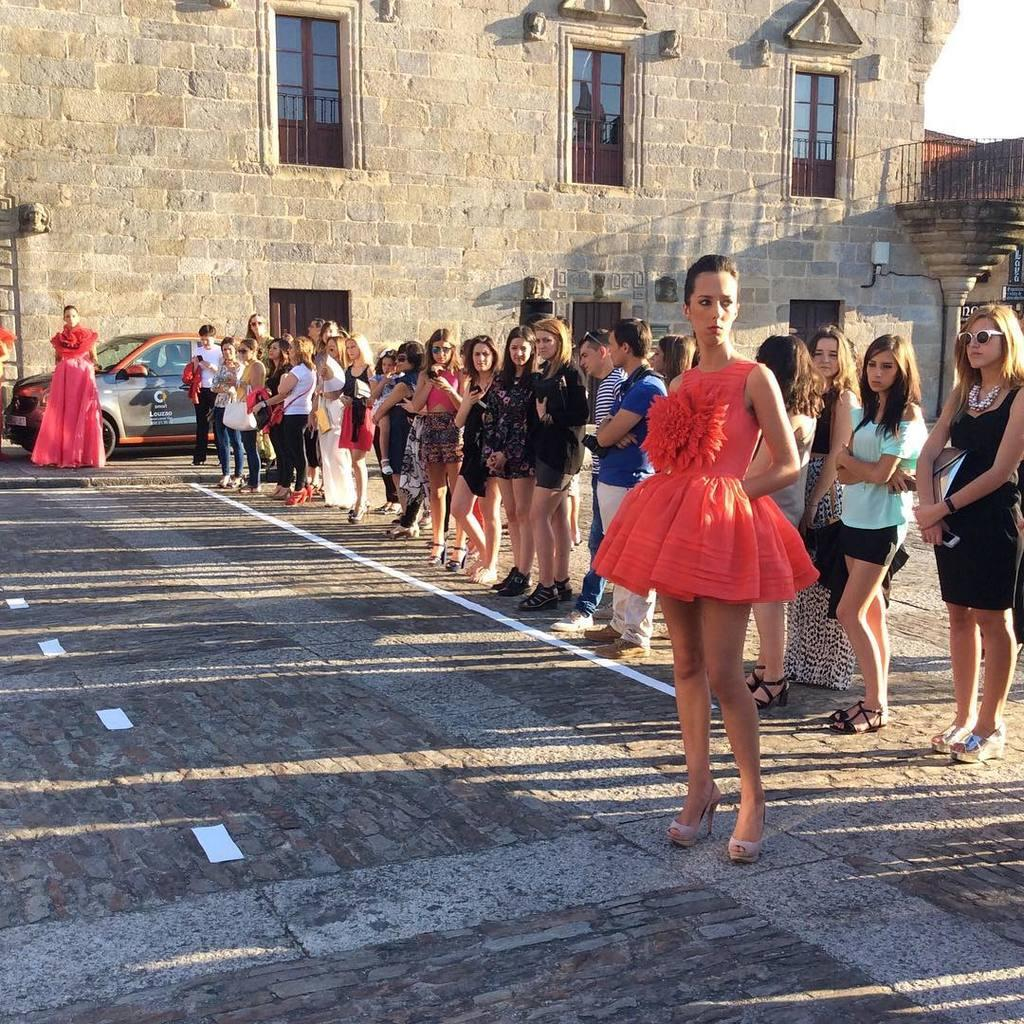What are the people in the image doing? The people in the image are standing on the ground. What else can be seen on the ground in the image? There is a car parked on the ground. What type of structure is present in the image? There is a building with pillars in the image. What features can be observed on the building? The building has windows. What is visible in the background of the image? The sky is visible in the image. What is the price of the vegetable being sold by the secretary in the image? There is no vegetable or secretary present in the image. What type of vegetable might be used to make a salad in the image? There is no vegetable or salad present in the image. 